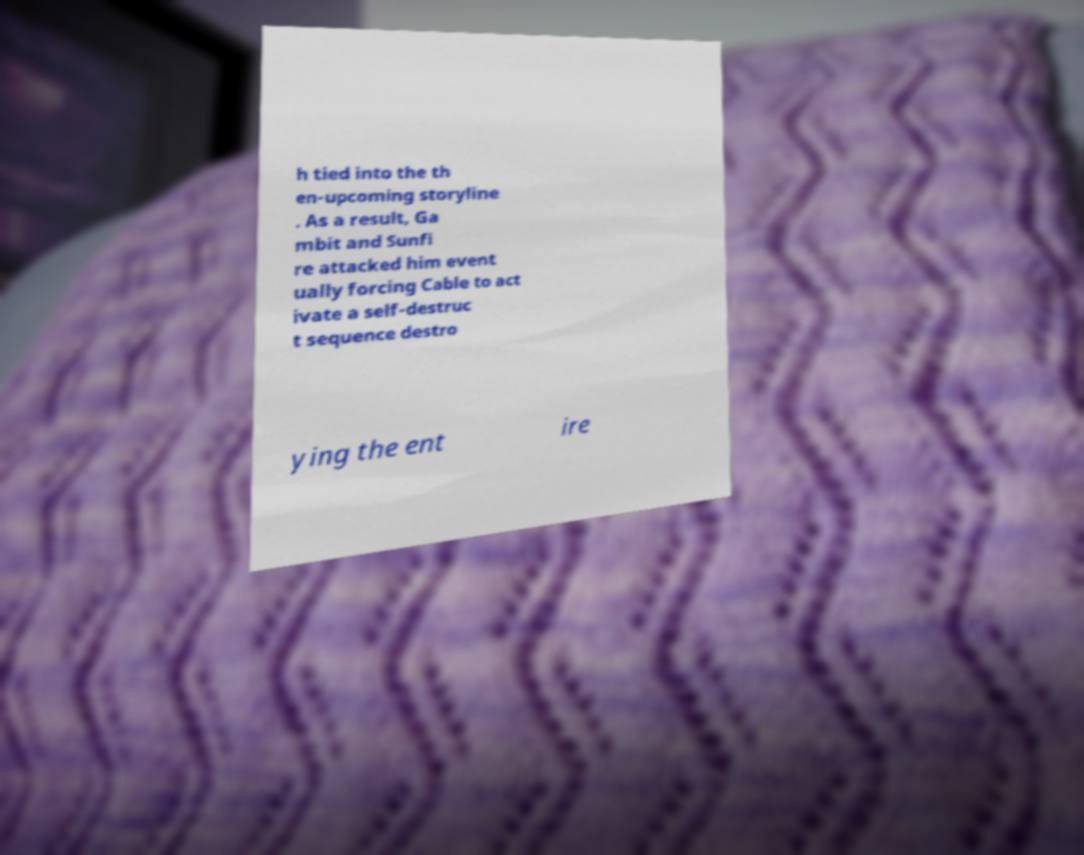Could you extract and type out the text from this image? h tied into the th en-upcoming storyline . As a result, Ga mbit and Sunfi re attacked him event ually forcing Cable to act ivate a self-destruc t sequence destro ying the ent ire 